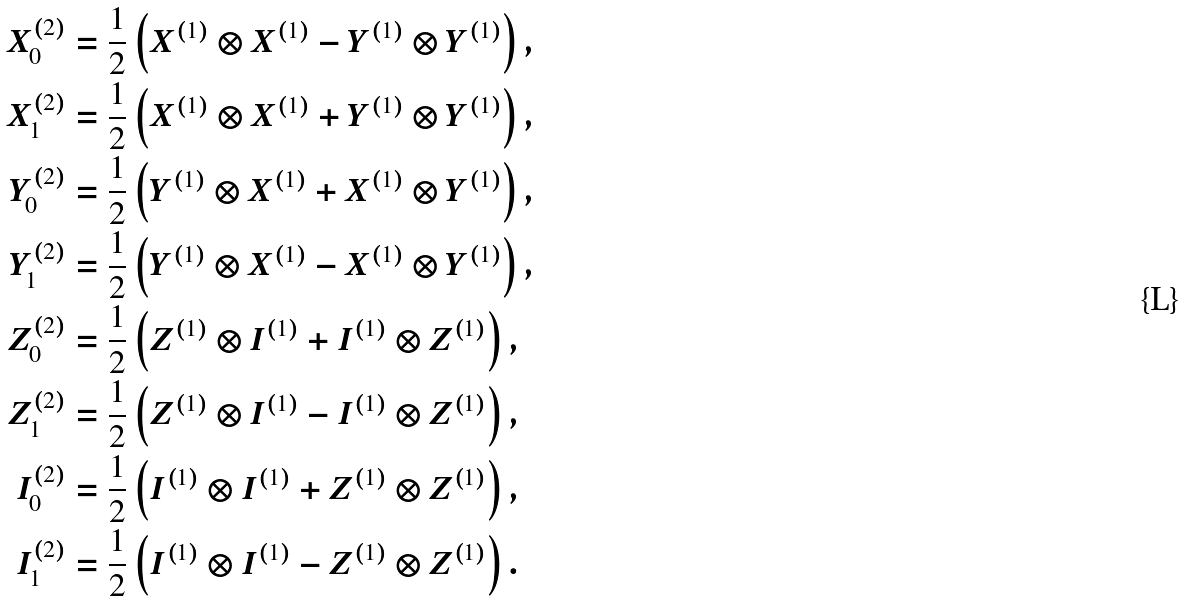Convert formula to latex. <formula><loc_0><loc_0><loc_500><loc_500>X _ { 0 } ^ { ( 2 ) } & = \frac { 1 } { 2 } \left ( X ^ { ( 1 ) } \otimes X ^ { ( 1 ) } - Y ^ { ( 1 ) } \otimes Y ^ { ( 1 ) } \right ) , \\ X _ { 1 } ^ { ( 2 ) } & = \frac { 1 } { 2 } \left ( X ^ { ( 1 ) } \otimes X ^ { ( 1 ) } + Y ^ { ( 1 ) } \otimes Y ^ { ( 1 ) } \right ) , \\ Y _ { 0 } ^ { ( 2 ) } & = \frac { 1 } { 2 } \left ( Y ^ { ( 1 ) } \otimes X ^ { ( 1 ) } + X ^ { ( 1 ) } \otimes Y ^ { ( 1 ) } \right ) , \\ Y _ { 1 } ^ { ( 2 ) } & = \frac { 1 } { 2 } \left ( Y ^ { ( 1 ) } \otimes X ^ { ( 1 ) } - X ^ { ( 1 ) } \otimes Y ^ { ( 1 ) } \right ) , \\ Z _ { 0 } ^ { ( 2 ) } & = \frac { 1 } { 2 } \left ( Z ^ { ( 1 ) } \otimes I ^ { ( 1 ) } + I ^ { ( 1 ) } \otimes Z ^ { ( 1 ) } \right ) , \\ Z _ { 1 } ^ { ( 2 ) } & = \frac { 1 } { 2 } \left ( Z ^ { ( 1 ) } \otimes I ^ { ( 1 ) } - I ^ { ( 1 ) } \otimes Z ^ { ( 1 ) } \right ) , \\ I _ { 0 } ^ { ( 2 ) } & = \frac { 1 } { 2 } \left ( I ^ { ( 1 ) } \otimes I ^ { ( 1 ) } + Z ^ { ( 1 ) } \otimes Z ^ { ( 1 ) } \right ) , \\ I _ { 1 } ^ { ( 2 ) } & = \frac { 1 } { 2 } \left ( I ^ { ( 1 ) } \otimes I ^ { ( 1 ) } - Z ^ { ( 1 ) } \otimes Z ^ { ( 1 ) } \right ) .</formula> 